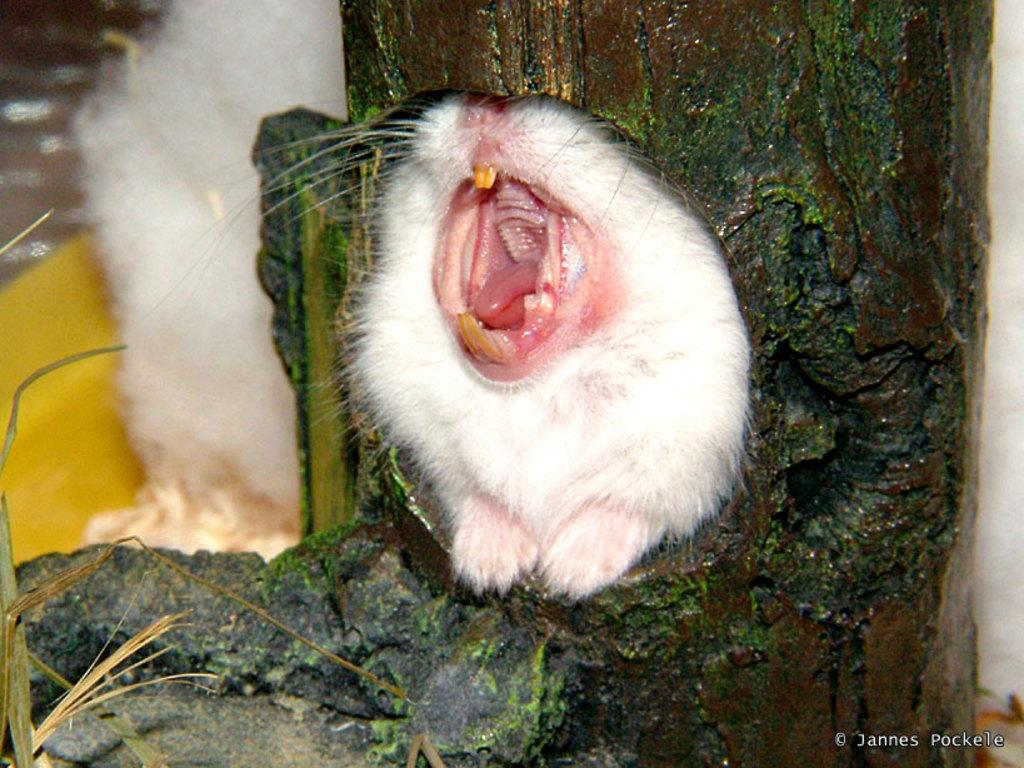What type of animal can be seen inside the bark of a tree in the image? There is a white animal inside the bark of a tree in the image. Are there any other similar animals in the image? Yes, there is another white animal on the left side of the image. What can be found at the bottom of the image? There is a logo at the bottom of the image. What type of shock can be seen coming from the finger of the person in the image? There is no person or finger present in the image; it features white animals and a logo. 